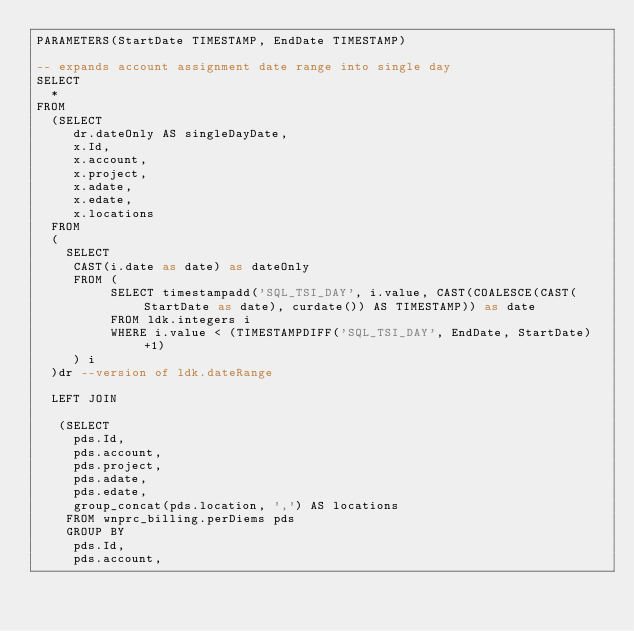<code> <loc_0><loc_0><loc_500><loc_500><_SQL_>PARAMETERS(StartDate TIMESTAMP, EndDate TIMESTAMP)

-- expands account assignment date range into single day
SELECT
  *
FROM
  (SELECT
     dr.dateOnly AS singleDayDate,
     x.Id,
     x.account,
     x.project,
     x.adate,
     x.edate,
     x.locations
  FROM
  (
    SELECT
     CAST(i.date as date) as dateOnly
     FROM (
          SELECT timestampadd('SQL_TSI_DAY', i.value, CAST(COALESCE(CAST(StartDate as date), curdate()) AS TIMESTAMP)) as date
          FROM ldk.integers i
          WHERE i.value < (TIMESTAMPDIFF('SQL_TSI_DAY', EndDate, StartDate)+1)
     ) i
  )dr --version of ldk.dateRange

  LEFT JOIN

   (SELECT
     pds.Id,
     pds.account,
     pds.project,
     pds.adate,
     pds.edate,
     group_concat(pds.location, ',') AS locations
    FROM wnprc_billing.perDiems pds
    GROUP BY
     pds.Id,
     pds.account,</code> 